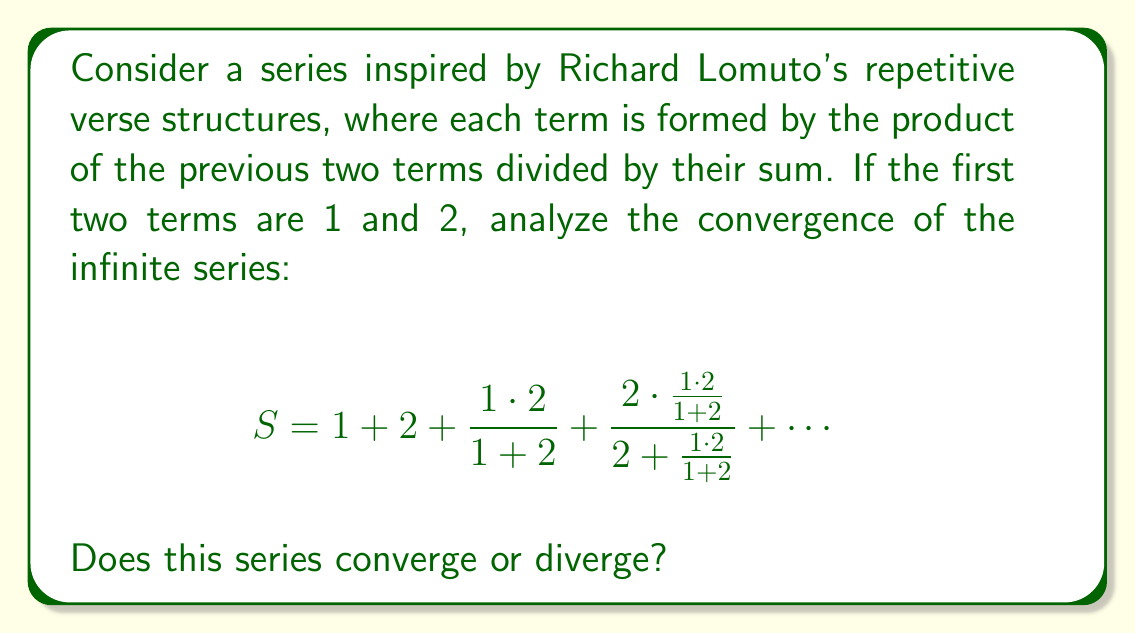Could you help me with this problem? To analyze the convergence of this series, let's follow these steps:

1) First, let's define the general term of the series. Let $a_n$ be the nth term of the series. We can write:

   $a_1 = 1$
   $a_2 = 2$
   $a_n = \frac{a_{n-2} \cdot a_{n-1}}{a_{n-2} + a_{n-1}}$ for $n \geq 3$

2) Let's calculate the first few terms:

   $a_3 = \frac{1 \cdot 2}{1 + 2} = \frac{2}{3}$
   $a_4 = \frac{2 \cdot \frac{2}{3}}{2 + \frac{2}{3}} = \frac{4}{8} = \frac{1}{2}$

3) We can observe that $a_n < 1$ for $n \geq 3$. Let's prove this by induction:

   Base case: We've shown $a_3 = \frac{2}{3} < 1$

   Inductive step: Assume $a_k < 1$ and $a_{k+1} < 1$ for some $k \geq 2$
   Then, $a_{k+2} = \frac{a_k \cdot a_{k+1}}{a_k + a_{k+1}} < \frac{1 \cdot 1}{a_k + a_{k+1}} < 1$

   Thus, by induction, $a_n < 1$ for all $n \geq 3$

4) Now, let's examine the limit of $a_n$ as $n$ approaches infinity:

   $\lim_{n \to \infty} a_n = \lim_{n \to \infty} \frac{a_{n-2} \cdot a_{n-1}}{a_{n-2} + a_{n-1}}$

   If this limit exists and equals $L$, then:

   $L = \frac{L \cdot L}{L + L} = \frac{L}{2}$

   This implies $L = 0$

5) Since $\lim_{n \to \infty} a_n = 0$, the series satisfies the necessary condition for convergence. However, this condition is not sufficient.

6) To determine convergence, we can use the ratio test:

   $\lim_{n \to \infty} |\frac{a_{n+1}}{a_n}| = \lim_{n \to \infty} |\frac{a_{n-1} \cdot a_n}{a_{n-1} + a_n} \cdot \frac{a_{n-2} + a_{n-1}}{a_{n-2} \cdot a_{n-1}}|$

   As $n$ approaches infinity, both $a_{n-2}$ and $a_{n-1}$ approach 0, so this limit equals 0.

7) Since the limit of the ratio test is less than 1, the series converges.
Answer: The series converges. 